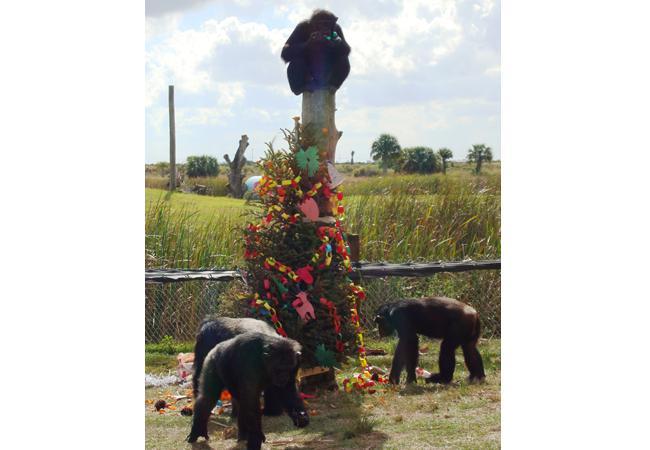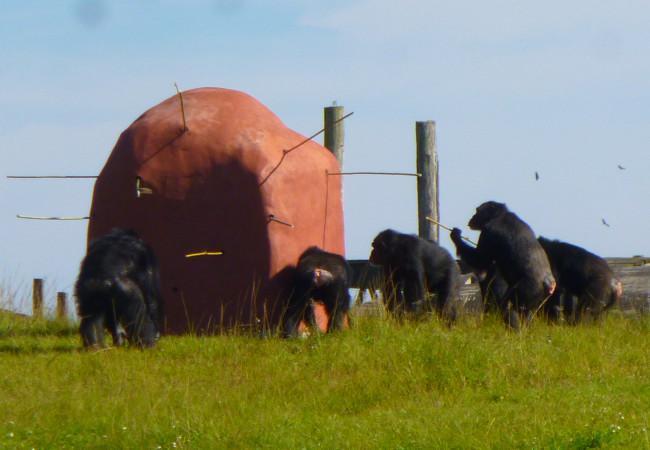The first image is the image on the left, the second image is the image on the right. Assess this claim about the two images: "There are more primates in the image on the right.". Correct or not? Answer yes or no. Yes. The first image is the image on the left, the second image is the image on the right. Given the left and right images, does the statement "One image shows a group of chimps outdoors in front of a brown squarish structure, and the other image shows chimps near a tree and manmade structures." hold true? Answer yes or no. Yes. 